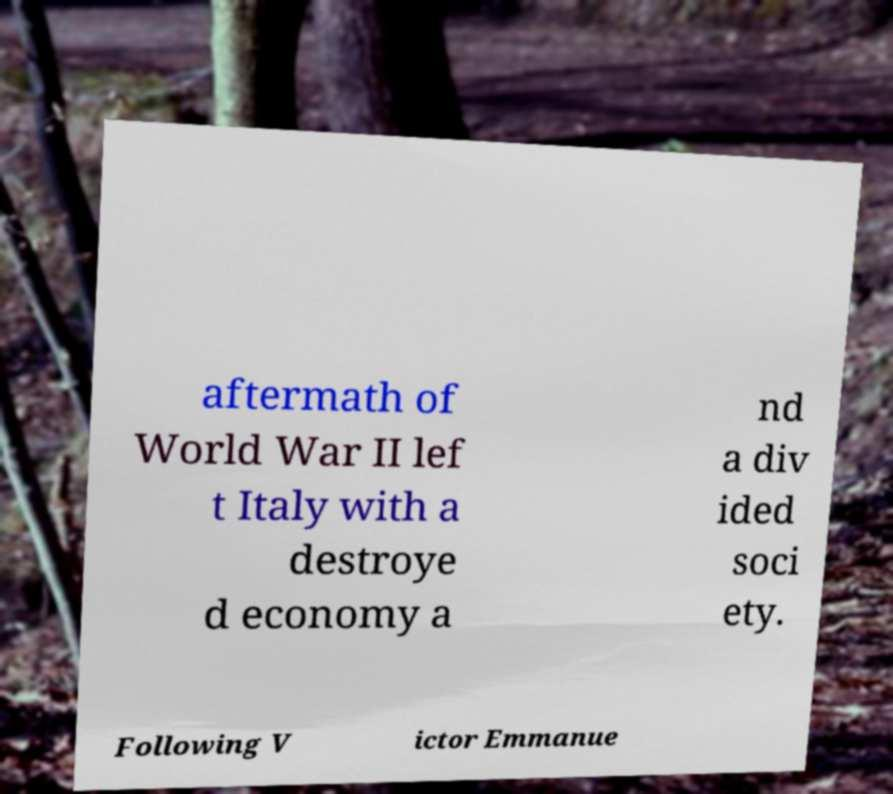Can you accurately transcribe the text from the provided image for me? aftermath of World War II lef t Italy with a destroye d economy a nd a div ided soci ety. Following V ictor Emmanue 